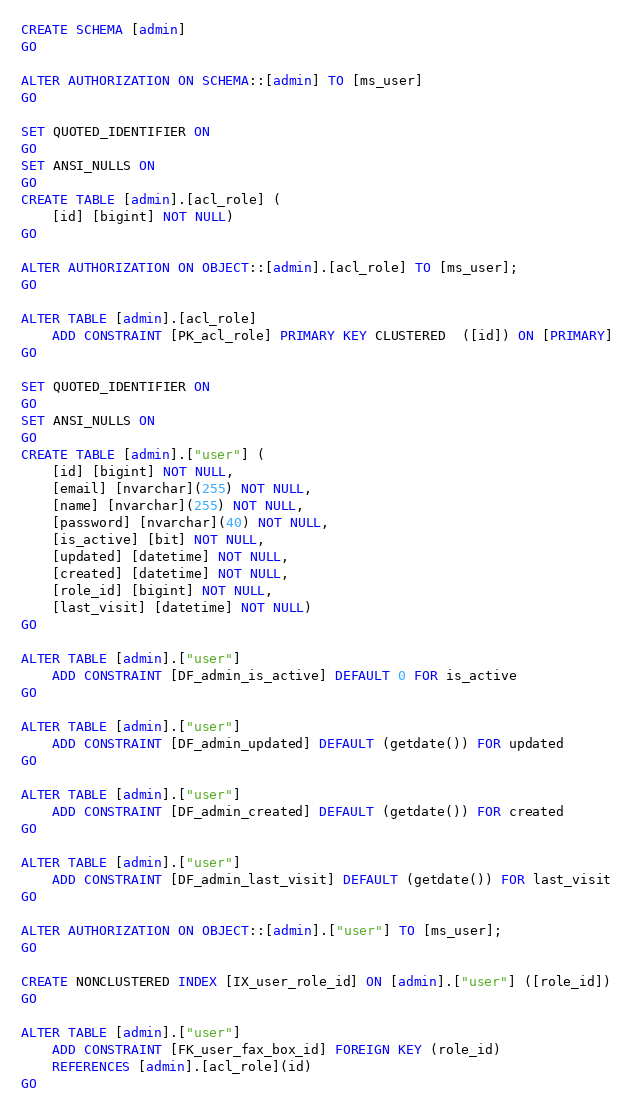<code> <loc_0><loc_0><loc_500><loc_500><_SQL_>CREATE SCHEMA [admin]
GO

ALTER AUTHORIZATION ON SCHEMA::[admin] TO [ms_user]
GO

SET QUOTED_IDENTIFIER ON
GO
SET ANSI_NULLS ON
GO
CREATE TABLE [admin].[acl_role] (
    [id] [bigint] NOT NULL)
GO

ALTER AUTHORIZATION ON OBJECT::[admin].[acl_role] TO [ms_user];    
GO

ALTER TABLE [admin].[acl_role] 
    ADD CONSTRAINT [PK_acl_role] PRIMARY KEY CLUSTERED  ([id]) ON [PRIMARY]
GO

SET QUOTED_IDENTIFIER ON
GO
SET ANSI_NULLS ON
GO
CREATE TABLE [admin].["user"] (
    [id] [bigint] NOT NULL,
    [email] [nvarchar](255) NOT NULL,
    [name] [nvarchar](255) NOT NULL,
    [password] [nvarchar](40) NOT NULL,
    [is_active] [bit] NOT NULL,
    [updated] [datetime] NOT NULL,
    [created] [datetime] NOT NULL,
    [role_id] [bigint] NOT NULL,
    [last_visit] [datetime] NOT NULL)
GO

ALTER TABLE [admin].["user"]
    ADD CONSTRAINT [DF_admin_is_active] DEFAULT 0 FOR is_active
GO

ALTER TABLE [admin].["user"] 
    ADD CONSTRAINT [DF_admin_updated] DEFAULT (getdate()) FOR updated
GO

ALTER TABLE [admin].["user"] 
    ADD CONSTRAINT [DF_admin_created] DEFAULT (getdate()) FOR created
GO

ALTER TABLE [admin].["user"]
    ADD CONSTRAINT [DF_admin_last_visit] DEFAULT (getdate()) FOR last_visit
GO

ALTER AUTHORIZATION ON OBJECT::[admin].["user"] TO [ms_user];    
GO

CREATE NONCLUSTERED INDEX [IX_user_role_id] ON [admin].["user"] ([role_id])
GO

ALTER TABLE [admin].["user"] 
    ADD CONSTRAINT [FK_user_fax_box_id] FOREIGN KEY (role_id) 
    REFERENCES [admin].[acl_role](id)
GO
</code> 